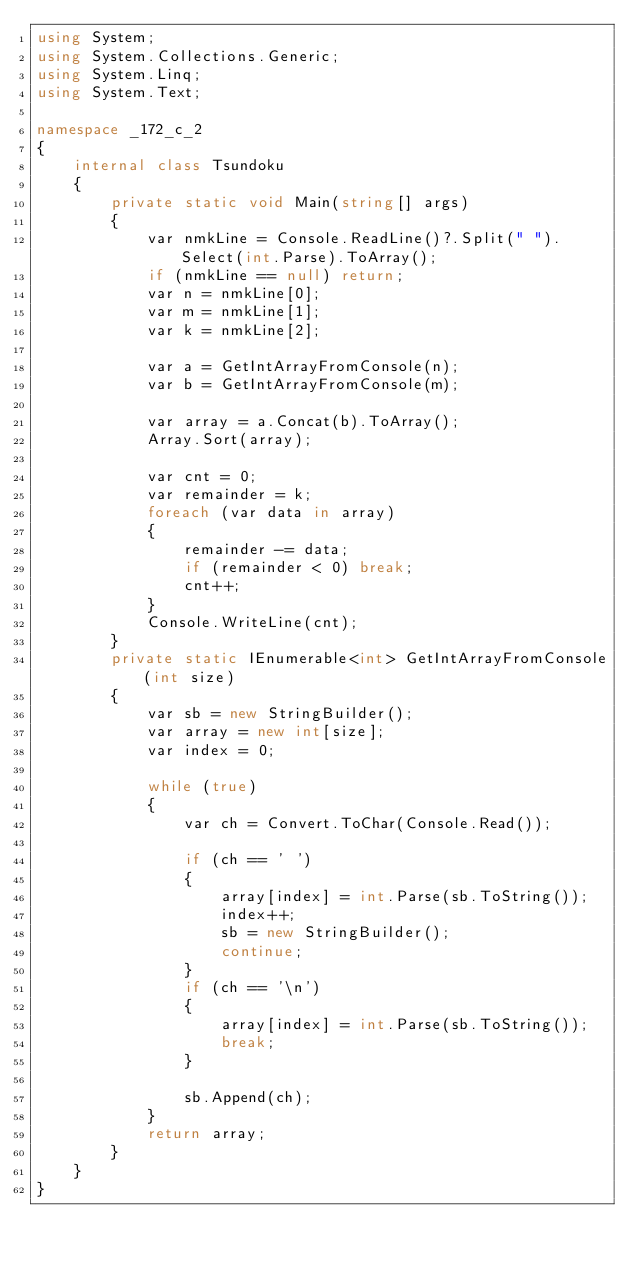<code> <loc_0><loc_0><loc_500><loc_500><_C#_>using System;
using System.Collections.Generic;
using System.Linq;
using System.Text;

namespace _172_c_2
{
    internal class Tsundoku
    {
        private static void Main(string[] args)
        {
            var nmkLine = Console.ReadLine()?.Split(" ").Select(int.Parse).ToArray();
            if (nmkLine == null) return;
            var n = nmkLine[0];
            var m = nmkLine[1];
            var k = nmkLine[2];

            var a = GetIntArrayFromConsole(n);
            var b = GetIntArrayFromConsole(m);

            var array = a.Concat(b).ToArray();
            Array.Sort(array);

            var cnt = 0;
            var remainder = k;
            foreach (var data in array)
            {
                remainder -= data;
                if (remainder < 0) break;
                cnt++;
            }
            Console.WriteLine(cnt);
        }
        private static IEnumerable<int> GetIntArrayFromConsole(int size)
        {
            var sb = new StringBuilder();
            var array = new int[size];
            var index = 0;

            while (true)
            {
                var ch = Convert.ToChar(Console.Read());

                if (ch == ' ')
                {
                    array[index] = int.Parse(sb.ToString());
                    index++;
                    sb = new StringBuilder();
                    continue;
                }
                if (ch == '\n')
                {
                    array[index] = int.Parse(sb.ToString());
                    break;
                }

                sb.Append(ch);
            }
            return array;
        }
    }
}
</code> 